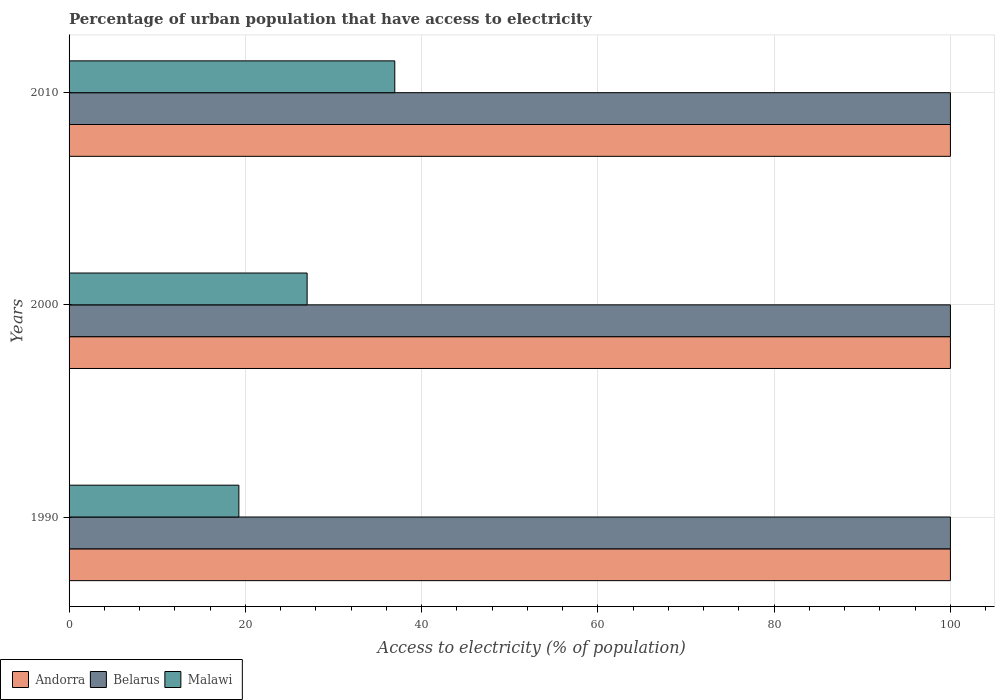How many different coloured bars are there?
Offer a terse response. 3. Are the number of bars on each tick of the Y-axis equal?
Your answer should be very brief. Yes. How many bars are there on the 2nd tick from the bottom?
Your response must be concise. 3. What is the label of the 3rd group of bars from the top?
Keep it short and to the point. 1990. In how many cases, is the number of bars for a given year not equal to the number of legend labels?
Offer a very short reply. 0. What is the percentage of urban population that have access to electricity in Belarus in 2000?
Give a very brief answer. 100. Across all years, what is the maximum percentage of urban population that have access to electricity in Malawi?
Your response must be concise. 36.96. Across all years, what is the minimum percentage of urban population that have access to electricity in Belarus?
Ensure brevity in your answer.  100. In which year was the percentage of urban population that have access to electricity in Andorra maximum?
Your answer should be very brief. 1990. In which year was the percentage of urban population that have access to electricity in Belarus minimum?
Provide a short and direct response. 1990. What is the total percentage of urban population that have access to electricity in Andorra in the graph?
Ensure brevity in your answer.  300. What is the difference between the percentage of urban population that have access to electricity in Belarus in 1990 and the percentage of urban population that have access to electricity in Malawi in 2000?
Your answer should be very brief. 72.99. In the year 2010, what is the difference between the percentage of urban population that have access to electricity in Belarus and percentage of urban population that have access to electricity in Andorra?
Offer a terse response. 0. In how many years, is the percentage of urban population that have access to electricity in Andorra greater than 76 %?
Keep it short and to the point. 3. Is the percentage of urban population that have access to electricity in Malawi in 2000 less than that in 2010?
Provide a succinct answer. Yes. What is the difference between the highest and the second highest percentage of urban population that have access to electricity in Andorra?
Provide a short and direct response. 0. What is the difference between the highest and the lowest percentage of urban population that have access to electricity in Belarus?
Your answer should be very brief. 0. In how many years, is the percentage of urban population that have access to electricity in Belarus greater than the average percentage of urban population that have access to electricity in Belarus taken over all years?
Offer a very short reply. 0. What does the 3rd bar from the top in 1990 represents?
Ensure brevity in your answer.  Andorra. What does the 1st bar from the bottom in 2000 represents?
Ensure brevity in your answer.  Andorra. Is it the case that in every year, the sum of the percentage of urban population that have access to electricity in Andorra and percentage of urban population that have access to electricity in Belarus is greater than the percentage of urban population that have access to electricity in Malawi?
Offer a terse response. Yes. How many bars are there?
Offer a very short reply. 9. Are all the bars in the graph horizontal?
Make the answer very short. Yes. Where does the legend appear in the graph?
Provide a short and direct response. Bottom left. How many legend labels are there?
Provide a succinct answer. 3. What is the title of the graph?
Make the answer very short. Percentage of urban population that have access to electricity. Does "Niger" appear as one of the legend labels in the graph?
Offer a very short reply. No. What is the label or title of the X-axis?
Keep it short and to the point. Access to electricity (% of population). What is the label or title of the Y-axis?
Keep it short and to the point. Years. What is the Access to electricity (% of population) of Malawi in 1990?
Your answer should be very brief. 19.27. What is the Access to electricity (% of population) in Belarus in 2000?
Your answer should be very brief. 100. What is the Access to electricity (% of population) of Malawi in 2000?
Offer a terse response. 27.01. What is the Access to electricity (% of population) of Andorra in 2010?
Offer a very short reply. 100. What is the Access to electricity (% of population) in Belarus in 2010?
Provide a succinct answer. 100. What is the Access to electricity (% of population) in Malawi in 2010?
Ensure brevity in your answer.  36.96. Across all years, what is the maximum Access to electricity (% of population) of Andorra?
Your answer should be very brief. 100. Across all years, what is the maximum Access to electricity (% of population) of Malawi?
Ensure brevity in your answer.  36.96. Across all years, what is the minimum Access to electricity (% of population) in Belarus?
Your response must be concise. 100. Across all years, what is the minimum Access to electricity (% of population) in Malawi?
Keep it short and to the point. 19.27. What is the total Access to electricity (% of population) of Andorra in the graph?
Your answer should be compact. 300. What is the total Access to electricity (% of population) of Belarus in the graph?
Provide a short and direct response. 300. What is the total Access to electricity (% of population) of Malawi in the graph?
Your answer should be compact. 83.23. What is the difference between the Access to electricity (% of population) in Belarus in 1990 and that in 2000?
Your answer should be very brief. 0. What is the difference between the Access to electricity (% of population) of Malawi in 1990 and that in 2000?
Provide a short and direct response. -7.74. What is the difference between the Access to electricity (% of population) in Malawi in 1990 and that in 2010?
Ensure brevity in your answer.  -17.69. What is the difference between the Access to electricity (% of population) of Malawi in 2000 and that in 2010?
Your response must be concise. -9.95. What is the difference between the Access to electricity (% of population) in Andorra in 1990 and the Access to electricity (% of population) in Malawi in 2000?
Make the answer very short. 72.99. What is the difference between the Access to electricity (% of population) in Belarus in 1990 and the Access to electricity (% of population) in Malawi in 2000?
Offer a very short reply. 72.99. What is the difference between the Access to electricity (% of population) in Andorra in 1990 and the Access to electricity (% of population) in Belarus in 2010?
Your answer should be very brief. 0. What is the difference between the Access to electricity (% of population) in Andorra in 1990 and the Access to electricity (% of population) in Malawi in 2010?
Keep it short and to the point. 63.04. What is the difference between the Access to electricity (% of population) of Belarus in 1990 and the Access to electricity (% of population) of Malawi in 2010?
Provide a succinct answer. 63.04. What is the difference between the Access to electricity (% of population) in Andorra in 2000 and the Access to electricity (% of population) in Belarus in 2010?
Your response must be concise. 0. What is the difference between the Access to electricity (% of population) of Andorra in 2000 and the Access to electricity (% of population) of Malawi in 2010?
Provide a succinct answer. 63.04. What is the difference between the Access to electricity (% of population) of Belarus in 2000 and the Access to electricity (% of population) of Malawi in 2010?
Offer a very short reply. 63.04. What is the average Access to electricity (% of population) of Belarus per year?
Make the answer very short. 100. What is the average Access to electricity (% of population) in Malawi per year?
Provide a succinct answer. 27.74. In the year 1990, what is the difference between the Access to electricity (% of population) in Andorra and Access to electricity (% of population) in Malawi?
Provide a succinct answer. 80.73. In the year 1990, what is the difference between the Access to electricity (% of population) of Belarus and Access to electricity (% of population) of Malawi?
Give a very brief answer. 80.73. In the year 2000, what is the difference between the Access to electricity (% of population) in Andorra and Access to electricity (% of population) in Malawi?
Provide a short and direct response. 72.99. In the year 2000, what is the difference between the Access to electricity (% of population) in Belarus and Access to electricity (% of population) in Malawi?
Give a very brief answer. 72.99. In the year 2010, what is the difference between the Access to electricity (% of population) in Andorra and Access to electricity (% of population) in Belarus?
Make the answer very short. 0. In the year 2010, what is the difference between the Access to electricity (% of population) in Andorra and Access to electricity (% of population) in Malawi?
Keep it short and to the point. 63.04. In the year 2010, what is the difference between the Access to electricity (% of population) of Belarus and Access to electricity (% of population) of Malawi?
Keep it short and to the point. 63.04. What is the ratio of the Access to electricity (% of population) in Belarus in 1990 to that in 2000?
Your response must be concise. 1. What is the ratio of the Access to electricity (% of population) in Malawi in 1990 to that in 2000?
Make the answer very short. 0.71. What is the ratio of the Access to electricity (% of population) in Malawi in 1990 to that in 2010?
Your answer should be very brief. 0.52. What is the ratio of the Access to electricity (% of population) in Malawi in 2000 to that in 2010?
Give a very brief answer. 0.73. What is the difference between the highest and the second highest Access to electricity (% of population) in Malawi?
Ensure brevity in your answer.  9.95. What is the difference between the highest and the lowest Access to electricity (% of population) of Andorra?
Keep it short and to the point. 0. What is the difference between the highest and the lowest Access to electricity (% of population) of Belarus?
Your response must be concise. 0. What is the difference between the highest and the lowest Access to electricity (% of population) of Malawi?
Keep it short and to the point. 17.69. 